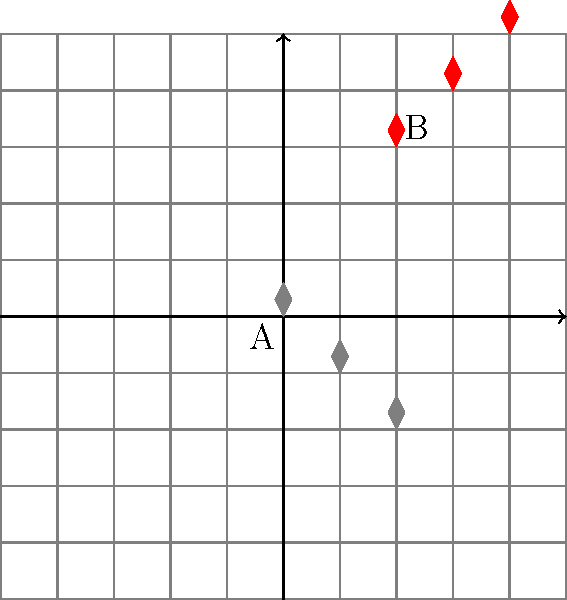In your latest crime novel, you've included a scene where the detective is analyzing a series of footprints left by a suspect. The original footprints start at point A (0,0) and follow a diagonal path. To determine the suspect's escape route, the detective needs to translate these footprints. If the first translated footprint is at point B (2,3), what is the translation vector that moves the original footprint series to the new position? To solve this problem, we need to follow these steps:

1. Identify the starting points:
   - Original footprints start at A(0,0)
   - Translated footprints start at B(2,3)

2. Determine the translation vector:
   - The translation vector is the difference between the new starting point and the original starting point.
   - We can represent this as a vector from A to B.

3. Calculate the components of the translation vector:
   - x-component: $2 - 0 = 2$
   - y-component: $3 - 0 = 3$

4. Express the translation vector:
   - The translation vector is $\vec{v} = \langle 2, 3 \rangle$

This vector $\langle 2, 3 \rangle$ represents the movement required to shift the original footprint series to its new position. In the context of the crime scene, this could indicate that the suspect moved 2 units to the right and 3 units up from their original path.
Answer: $\langle 2, 3 \rangle$ 